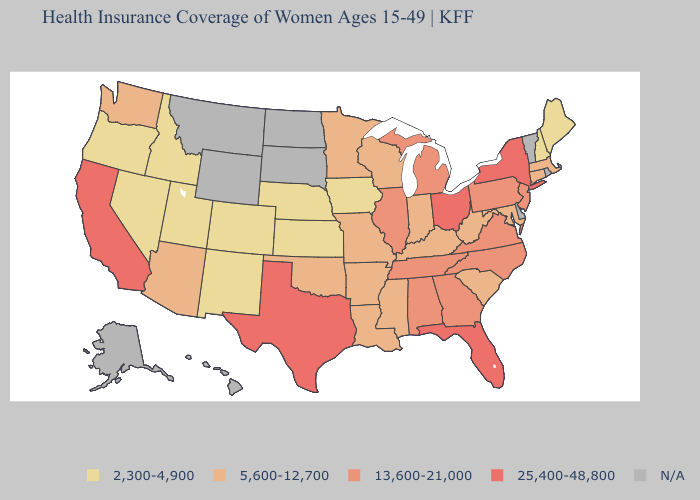Does Pennsylvania have the lowest value in the Northeast?
Concise answer only. No. Does Oregon have the lowest value in the USA?
Write a very short answer. Yes. Name the states that have a value in the range 25,400-48,800?
Keep it brief. California, Florida, New York, Ohio, Texas. What is the value of Alabama?
Keep it brief. 13,600-21,000. What is the value of Arkansas?
Quick response, please. 5,600-12,700. Among the states that border North Carolina , does South Carolina have the highest value?
Write a very short answer. No. What is the value of Michigan?
Give a very brief answer. 13,600-21,000. Name the states that have a value in the range N/A?
Answer briefly. Alaska, Delaware, Hawaii, Montana, North Dakota, Rhode Island, South Dakota, Vermont, Wyoming. What is the lowest value in the USA?
Write a very short answer. 2,300-4,900. Does Georgia have the highest value in the USA?
Concise answer only. No. How many symbols are there in the legend?
Keep it brief. 5. Among the states that border Iowa , which have the highest value?
Be succinct. Illinois. What is the highest value in the USA?
Concise answer only. 25,400-48,800. What is the value of Arkansas?
Give a very brief answer. 5,600-12,700. What is the highest value in the USA?
Concise answer only. 25,400-48,800. 